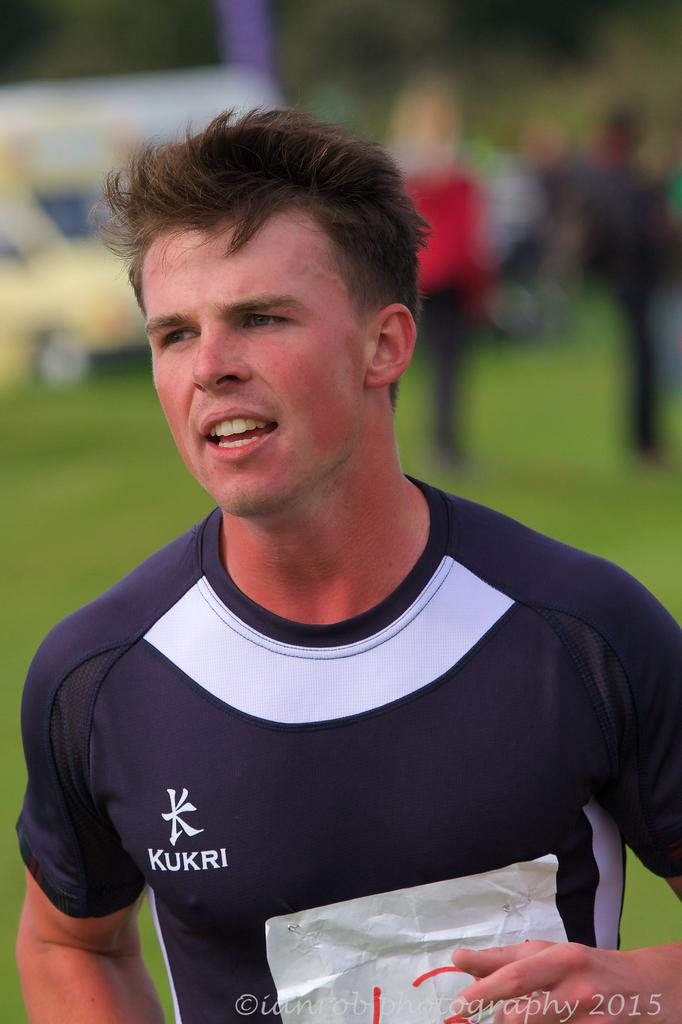<image>
Provide a brief description of the given image. the name Kukri that is on a jersey 